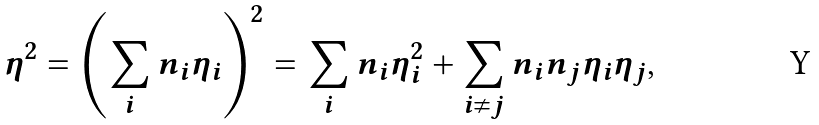<formula> <loc_0><loc_0><loc_500><loc_500>\eta ^ { 2 } = \left ( \sum _ { i } n _ { i } \eta _ { i } \right ) ^ { 2 } = \sum _ { i } n _ { i } \eta _ { i } ^ { 2 } + \sum _ { i \ne j } n _ { i } n _ { j } \eta _ { i } \eta _ { j } ,</formula> 